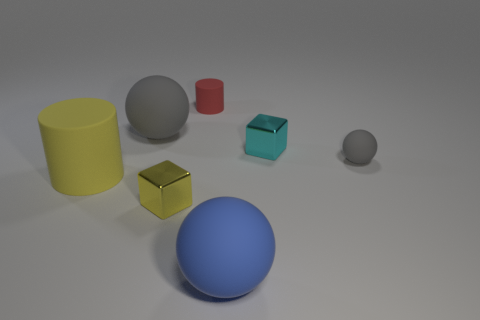There is a tiny rubber object that is right of the shiny cube that is behind the rubber cylinder that is to the left of the yellow metal cube; what is its shape? The tiny rubber object to the right of the shiny cube, which is located behind the rubber cylinder to the left of the yellow metal cube, is spherical in shape. 